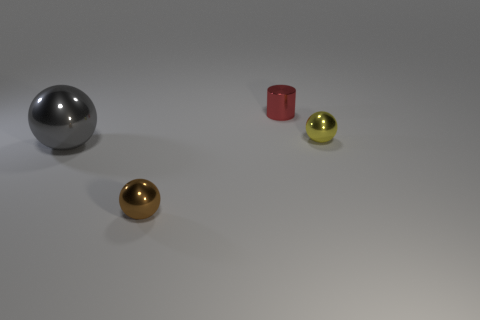Do the small metal object that is on the left side of the tiny shiny cylinder and the tiny thing that is right of the red cylinder have the same shape?
Offer a very short reply. Yes. There is a sphere that is on the right side of the tiny ball left of the small shiny ball that is to the right of the brown sphere; what is it made of?
Ensure brevity in your answer.  Metal. There is a red shiny object that is the same size as the brown shiny object; what shape is it?
Provide a short and direct response. Cylinder. How big is the gray object?
Ensure brevity in your answer.  Large. What number of things are on the right side of the tiny shiny thing that is left of the small shiny thing behind the small yellow sphere?
Give a very brief answer. 2. There is a object right of the tiny red shiny object; what shape is it?
Your response must be concise. Sphere. What number of other things are there of the same material as the gray ball
Provide a succinct answer. 3. Are there fewer gray balls in front of the brown object than gray objects that are to the left of the small metal cylinder?
Make the answer very short. Yes. There is a big thing that is the same shape as the tiny yellow metal object; what color is it?
Offer a terse response. Gray. There is a thing that is behind the yellow object; does it have the same size as the large gray metallic sphere?
Your answer should be compact. No. 